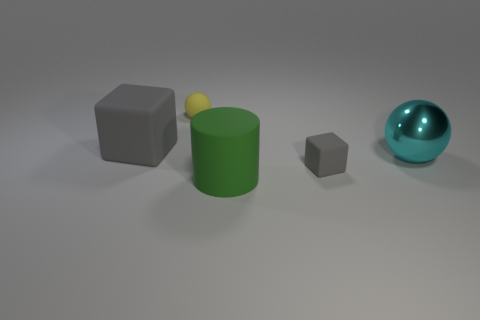Add 1 big spheres. How many objects exist? 6 Subtract all cubes. How many objects are left? 3 Add 1 cubes. How many cubes exist? 3 Subtract 0 purple spheres. How many objects are left? 5 Subtract all big purple objects. Subtract all big green matte cylinders. How many objects are left? 4 Add 3 tiny cubes. How many tiny cubes are left? 4 